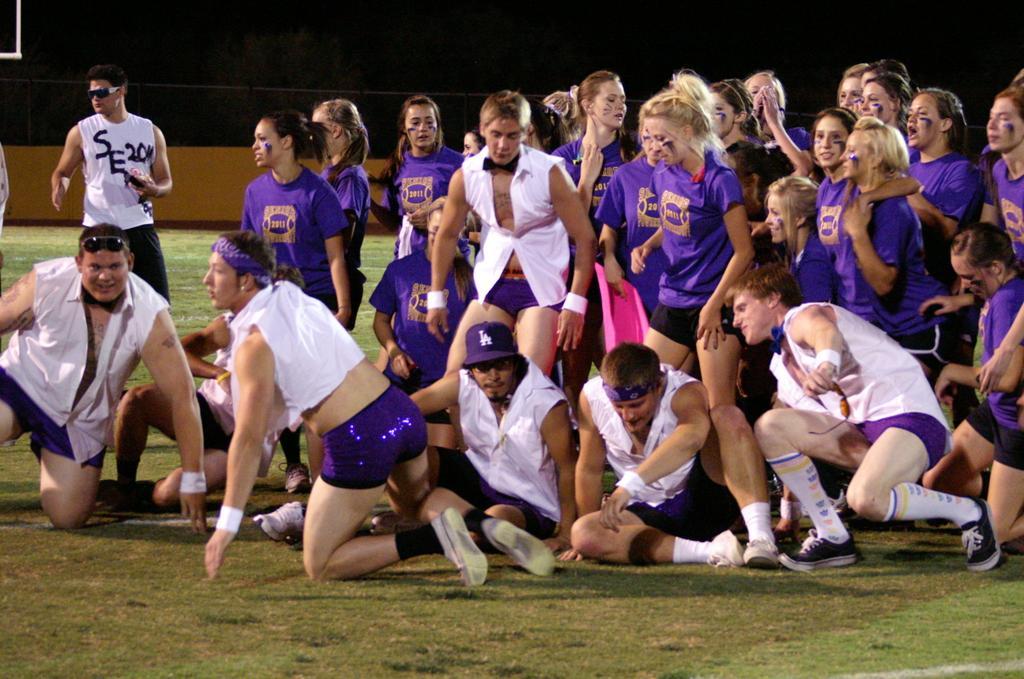In one or two sentences, can you explain what this image depicts? In this image I can see few people are wearing white and purple dress. I can see few are standing and few are sitting. Background is in black and brown color. 